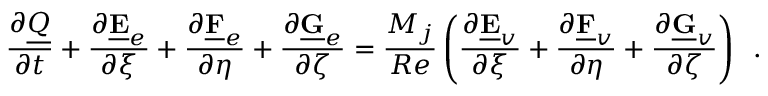Convert formula to latex. <formula><loc_0><loc_0><loc_500><loc_500>\frac { \partial \underline { Q } } { \partial t } + \frac { \partial \underline { E } _ { e } } { \partial \xi } + \frac { \partial \underline { F } _ { e } } { \partial \eta } + \frac { \partial \underline { G } _ { e } } { \partial \zeta } = \frac { M _ { j } } { R e } \left ( \frac { \partial \underline { E } _ { v } } { \partial \xi } + \frac { \partial \underline { F } _ { v } } { \partial \eta } + \frac { \partial \underline { G } _ { v } } { \partial \zeta } \right ) \, .</formula> 